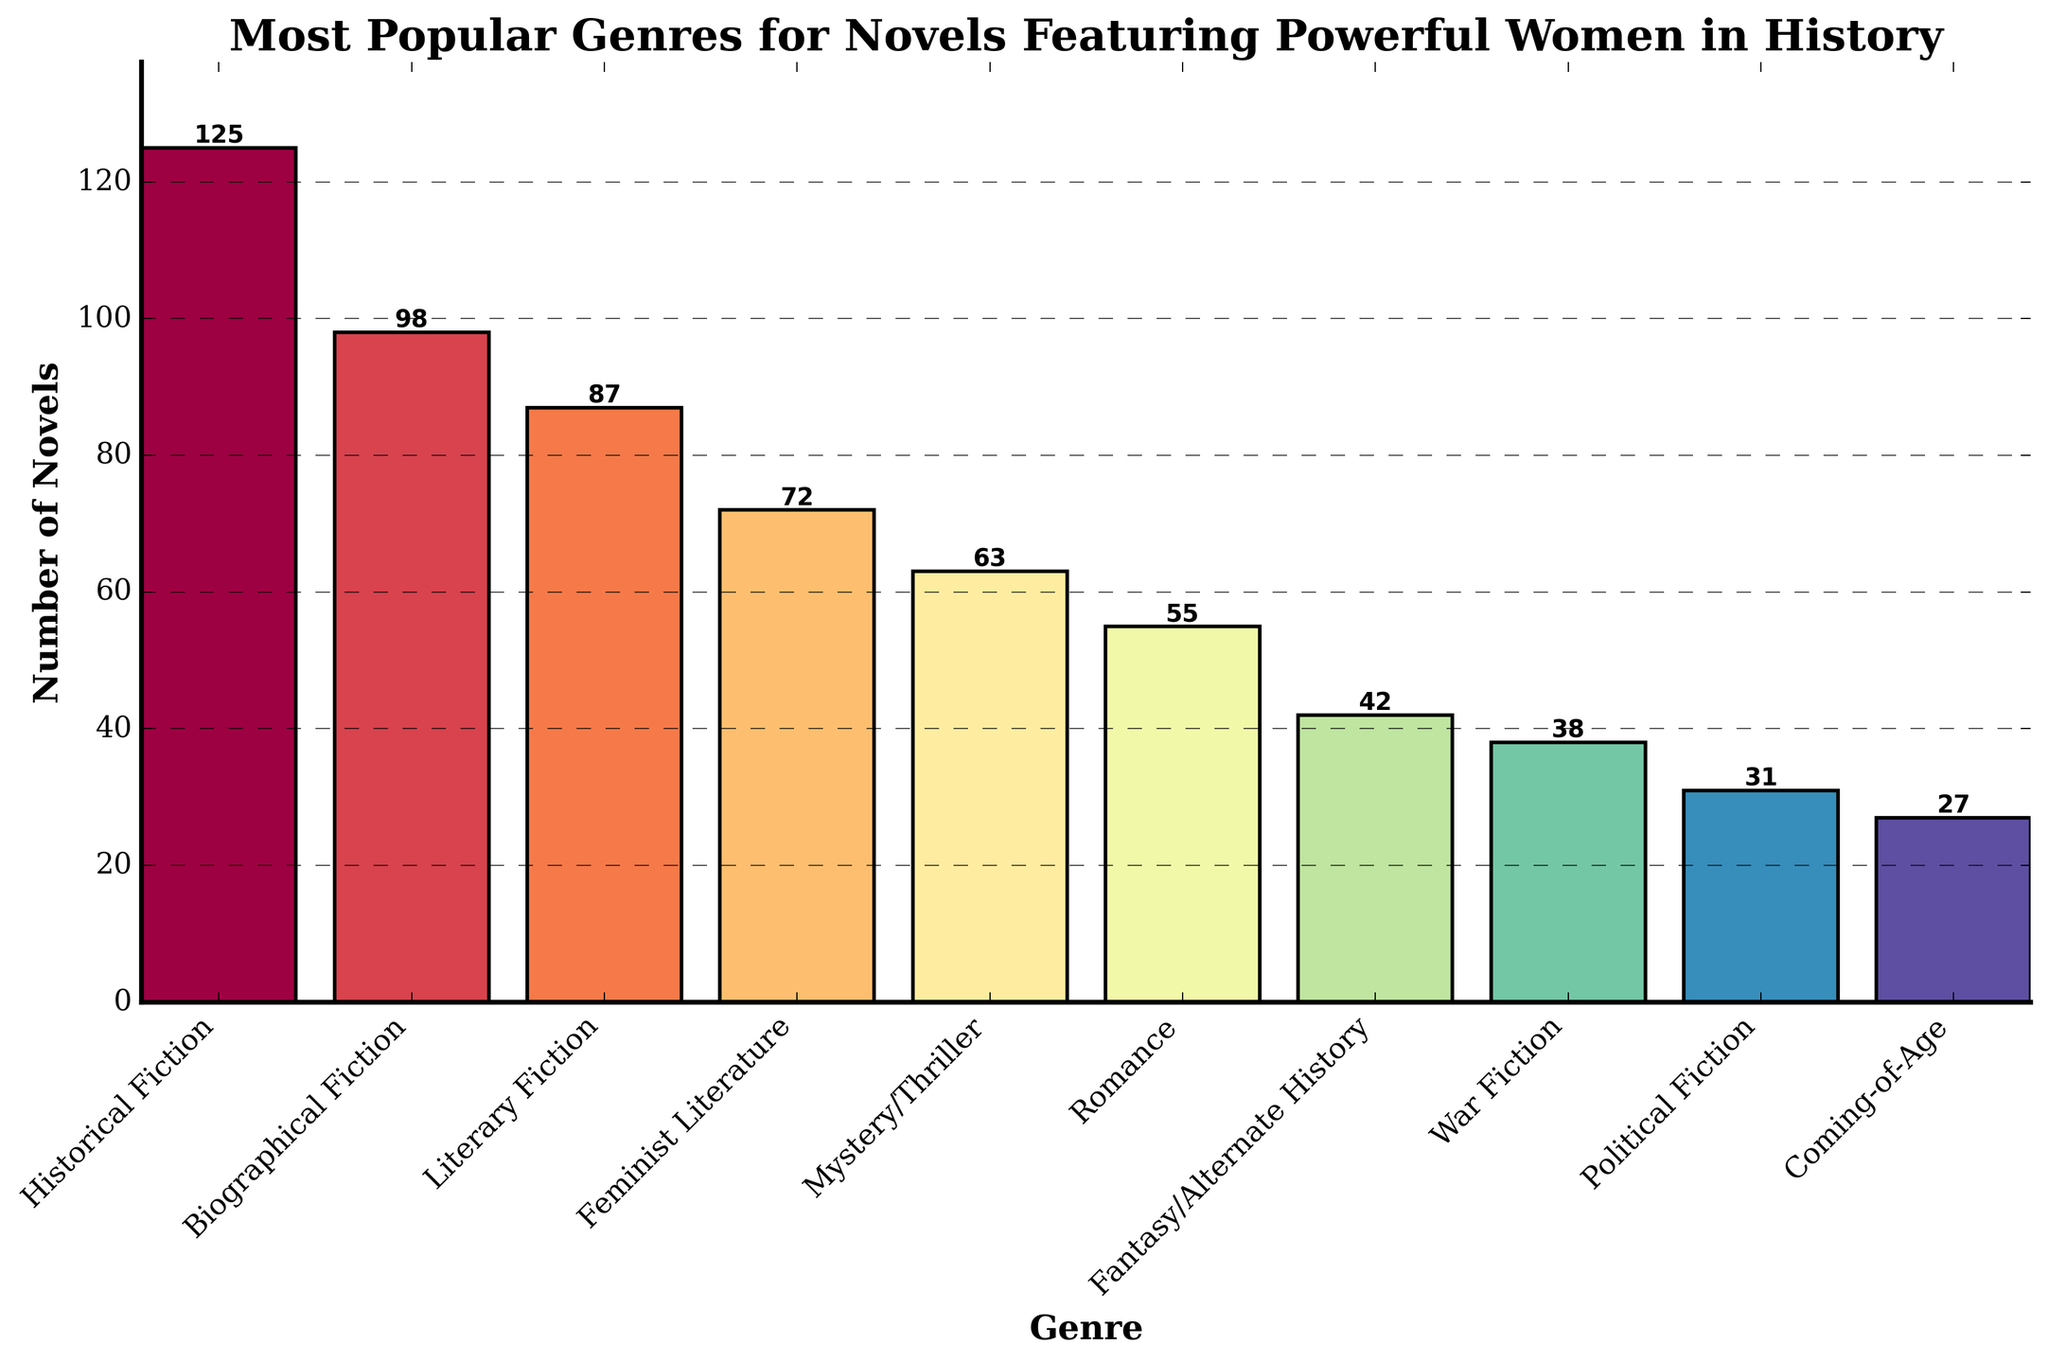What is the most popular genre for novels featuring powerful women in history? The bar chart shows the number of novels in each genre, with the highest bar representing the most popular genre. "Historical Fiction" has the highest number of novels.
Answer: Historical Fiction How many more novels are in the "Biographical Fiction" genre compared to the "Coming-of-Age" genre? The number of novels in "Biographical Fiction" is 98, and in "Coming-of-Age" is 27. Subtracting these gives 98 - 27 = 71.
Answer: 71 What is the combined total of novels in the "Mystery/Thriller" and "Romance" genres? The number of novels in "Mystery/Thriller" is 63 and in "Romance" is 55. Adding these together gives 63 + 55 = 118.
Answer: 118 Which genre has the second fewest novels, and how many does it have? The bar chart shows that "Coming-of-Age" has the fewest novels with 27. The second fewest is "Political Fiction" with 31 novels.
Answer: Political Fiction, 31 Which genres have more novels than "Fantasy/Alternate History"? The number of novels in "Fantasy/Alternate History" is 42. The genres with more novels are "Historical Fiction", "Biographical Fiction", "Literary Fiction", "Feminist Literature", "Mystery/Thriller", and "Romance".
Answer: Historical Fiction, Biographical Fiction, Literary Fiction, Feminist Literature, Mystery/Thriller, Romance What is the average number of novels for the top three genres? The top three genres are "Historical Fiction" (125 novels), "Biographical Fiction" (98 novels), and "Literary Fiction" (87 novels). Adding these gives 125 + 98 + 87 = 310. Dividing by 3 gives 310 / 3 ≈ 103.33.
Answer: 103.33 What is the difference in the number of novels between the "Fantasy/Alternate History" and "War Fiction" genres? The number of novels in "Fantasy/Alternate History" is 42, and in "War Fiction" is 38. Subtracting these gives 42 - 38 = 4.
Answer: 4 Which genre is represented by the tallest bar, and what is its height? The tallest bar in the bar chart represents the genre with the highest number of novels. "Historical Fiction" has the tallest bar with a height of 125.
Answer: Historical Fiction, 125 Considering the genres with fewer than 50 novels, what is their combined total? The genres with fewer than 50 novels are "Fantasy/Alternate History" (42), "War Fiction" (38), "Political Fiction" (31), and "Coming-of-Age" (27). Adding these gives 42 + 38 + 31 + 27 = 138.
Answer: 138 Which genre's bar color visually stands out the most due to its position in the color spectrum? The bars are colored using the Spectral color map, which produces a gradient effect. The "Historical Fiction" genre's bar is the tallest and its color stands out prominently, likely towards the middle of the spectrum, making it visually striking.
Answer: Historical Fiction 